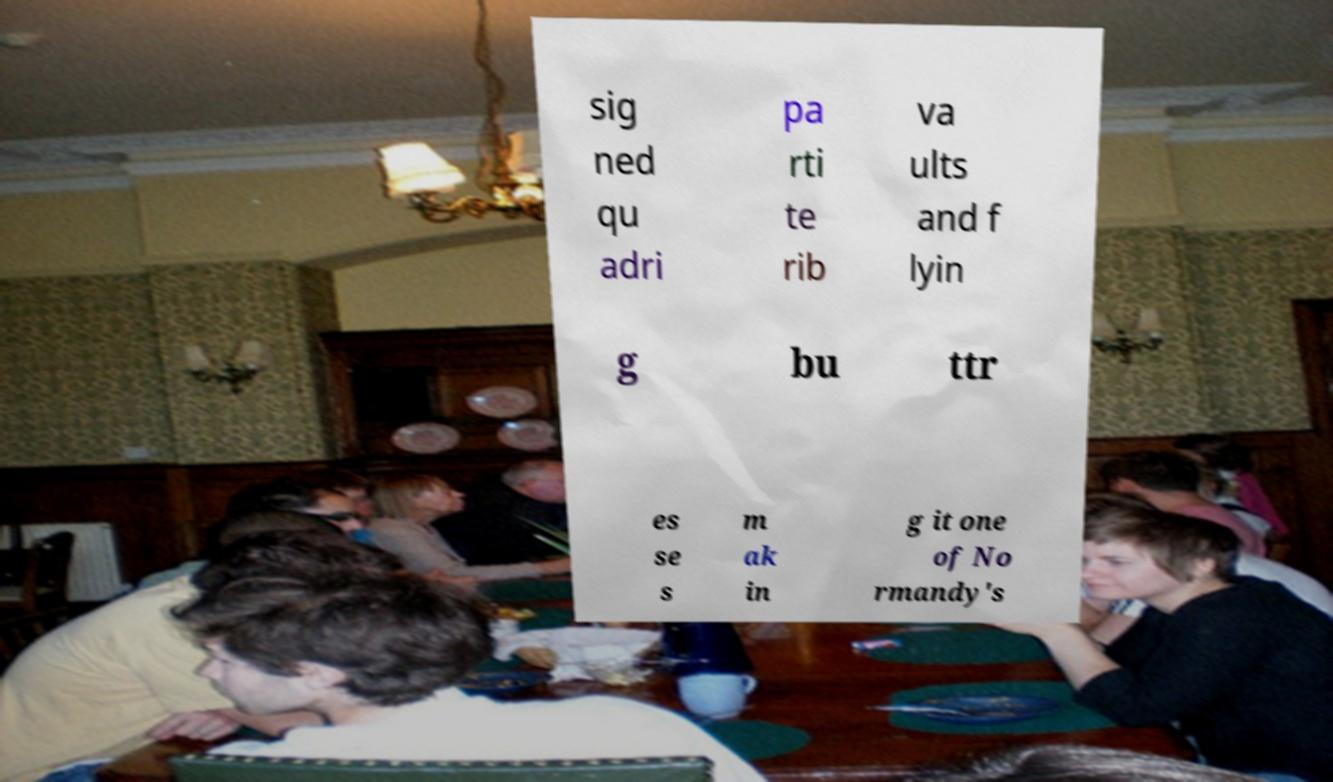Please read and relay the text visible in this image. What does it say? sig ned qu adri pa rti te rib va ults and f lyin g bu ttr es se s m ak in g it one of No rmandy's 